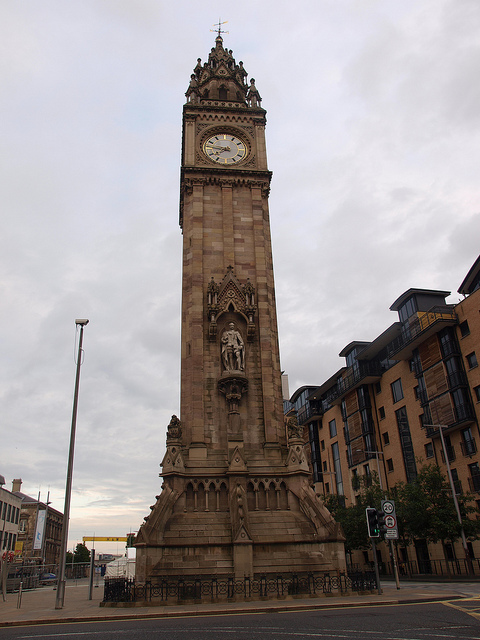<image>What are the statues in the background of? It is unknown what the statues in the background are of. It can be 'city', 'angels', 'man', 'saints', 'clock', 'person', or 'notable figures'. Where is the famous landmark in the picture? I don't know where the famous landmark in the picture is. It could be in New York, England, London, France, or it could be Big Ben. What are the statues in the background of? I don't know what the statues in the background are. They can be angels, saints, or notable figures. Where is the famous landmark in the picture? I don't know where the famous landmark is in the picture. It can be located in New York, London, or France. 